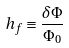<formula> <loc_0><loc_0><loc_500><loc_500>h _ { f } \equiv \frac { \delta \Phi } { \Phi _ { 0 } }</formula> 